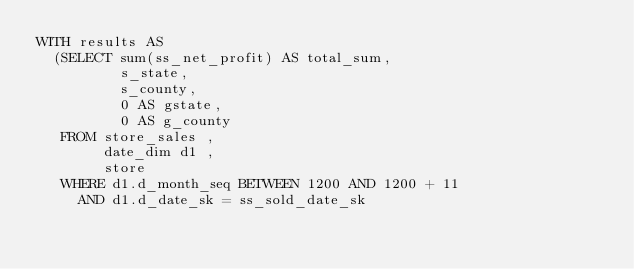<code> <loc_0><loc_0><loc_500><loc_500><_SQL_>WITH results AS
  (SELECT sum(ss_net_profit) AS total_sum,
          s_state,
          s_county,
          0 AS gstate,
          0 AS g_county
   FROM store_sales ,
        date_dim d1 ,
        store
   WHERE d1.d_month_seq BETWEEN 1200 AND 1200 + 11
     AND d1.d_date_sk = ss_sold_date_sk</code> 